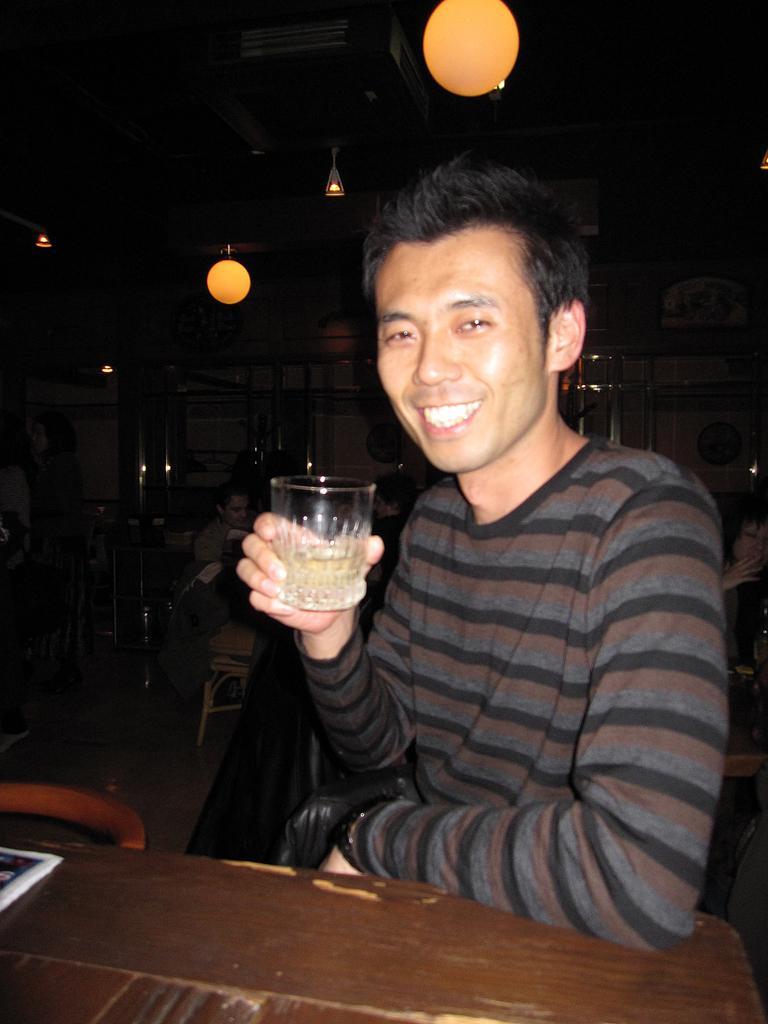Can you describe this image briefly? In this image I can see a man who is holding a glass of wine in his hand and smiling. 